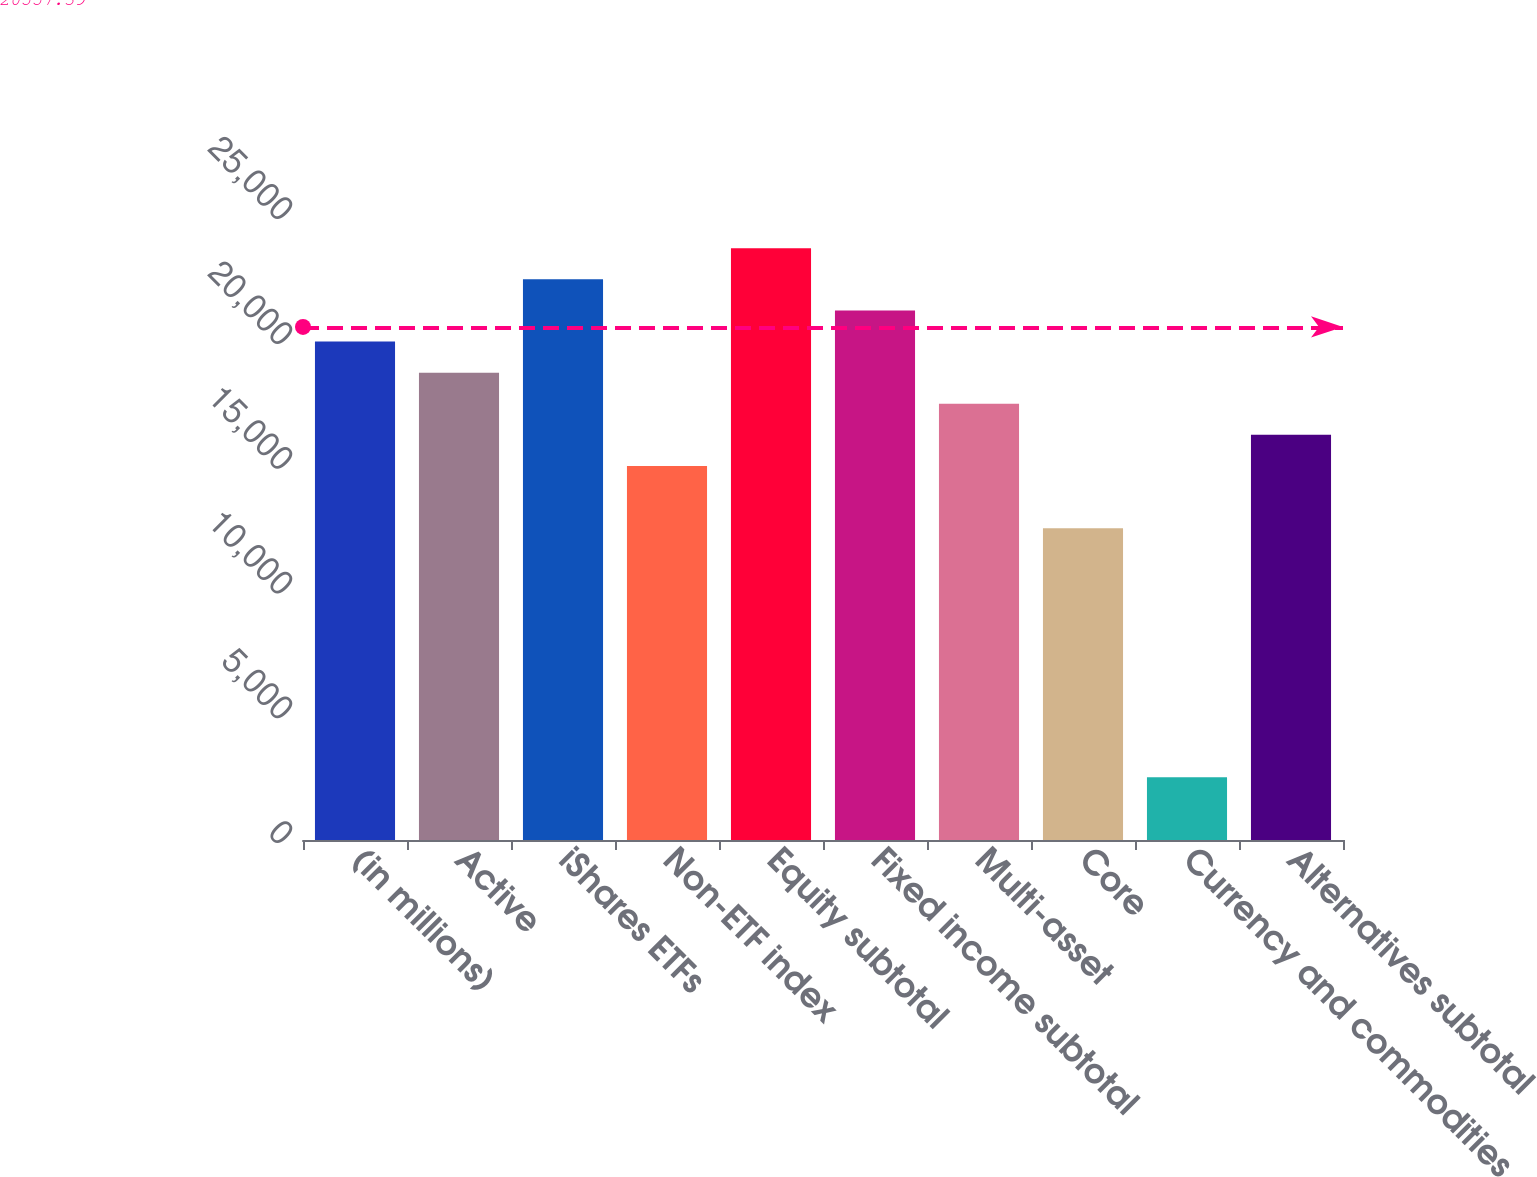<chart> <loc_0><loc_0><loc_500><loc_500><bar_chart><fcel>(in millions)<fcel>Active<fcel>iShares ETFs<fcel>Non-ETF index<fcel>Equity subtotal<fcel>Fixed income subtotal<fcel>Multi-asset<fcel>Core<fcel>Currency and commodities<fcel>Alternatives subtotal<nl><fcel>19971.2<fcel>18724.5<fcel>22464.6<fcel>14984.4<fcel>23711.3<fcel>21217.9<fcel>17477.8<fcel>12491<fcel>2517.4<fcel>16231.1<nl></chart> 